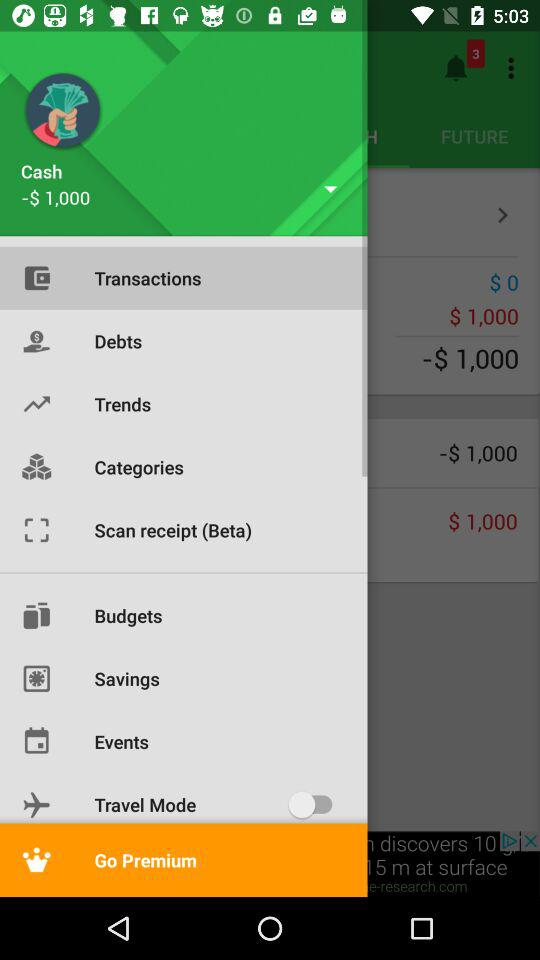What is the cash balance? The cash balance is -$1,000. 